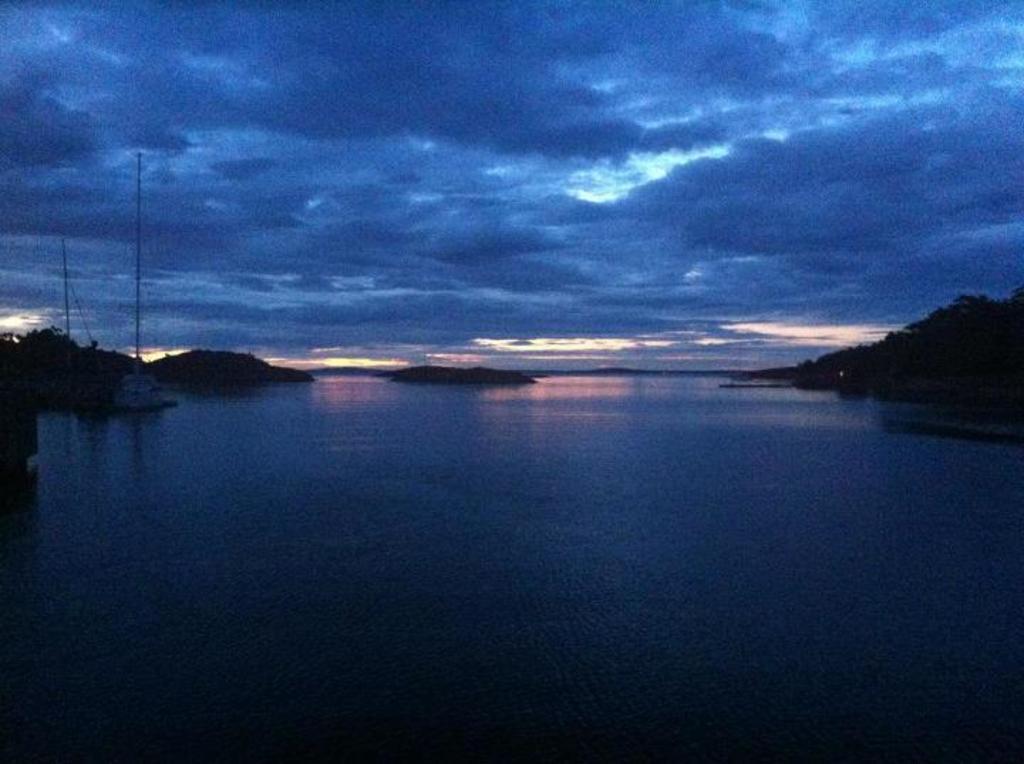Please provide a concise description of this image. In this image, we can see a boat is on the water. Here we can see poles, mountains and clouds sky. 